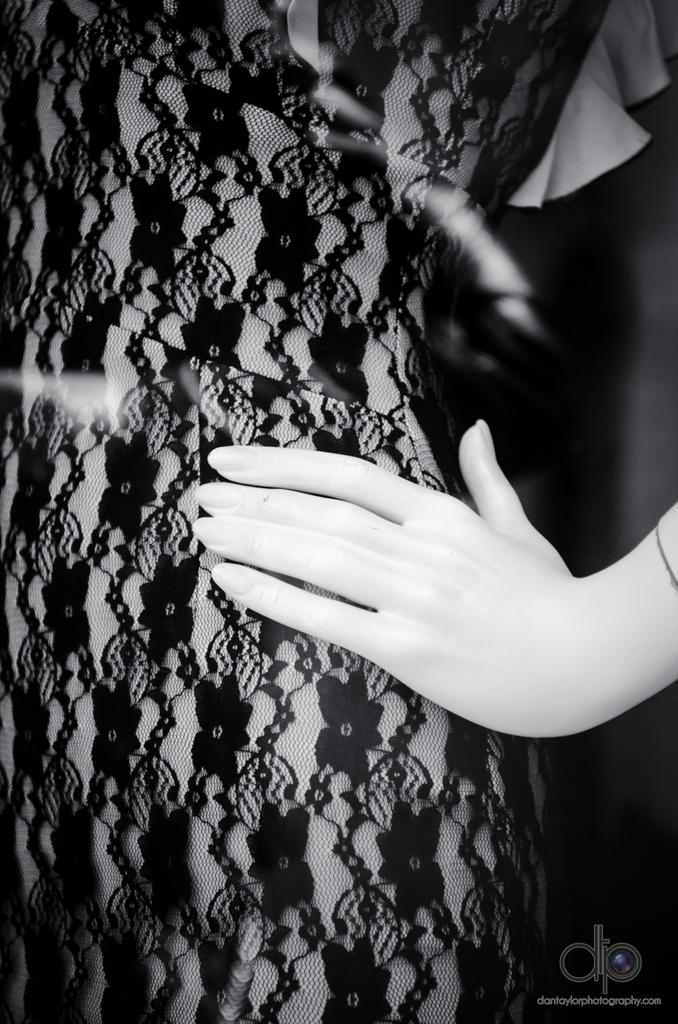What is the main subject of the image? There is a mannequin of a woman in the image. What is the mannequin wearing? The mannequin is wearing a black dress. What color is the background of the image? The background of the image is black in color. How is the background of the image depicted? The background of the image is blurred. Can you tell me how many toes the mannequin has on its left foot? The mannequin does not have toes, as it is not a real person but a representation made of materials. 